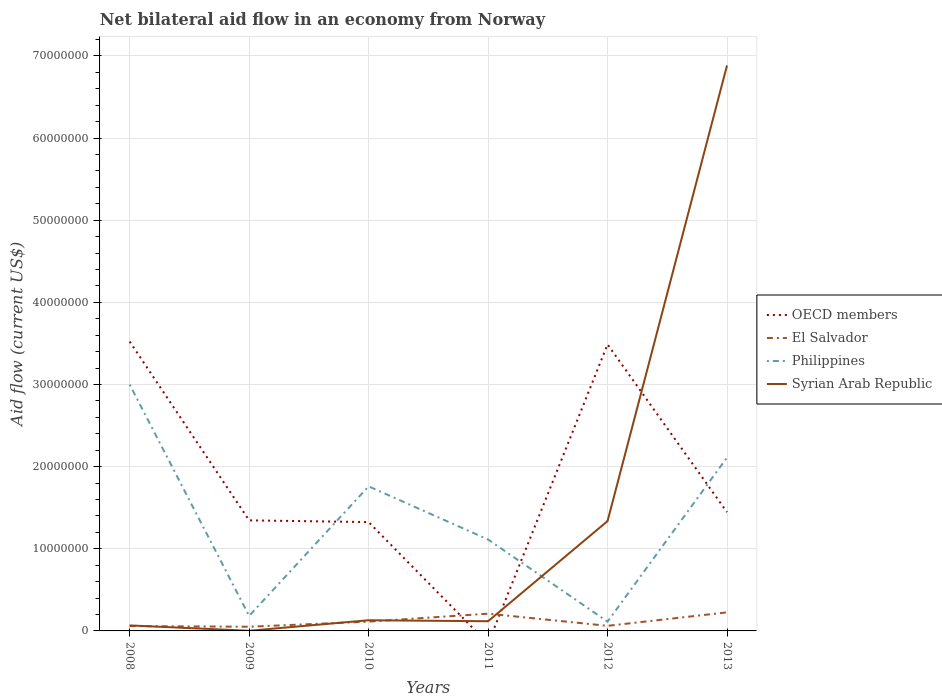Does the line corresponding to El Salvador intersect with the line corresponding to OECD members?
Make the answer very short. Yes. Is the number of lines equal to the number of legend labels?
Ensure brevity in your answer.  No. Across all years, what is the maximum net bilateral aid flow in El Salvador?
Provide a succinct answer. 5.10e+05. What is the total net bilateral aid flow in El Salvador in the graph?
Make the answer very short. 8.00e+04. What is the difference between the highest and the second highest net bilateral aid flow in Philippines?
Provide a short and direct response. 2.89e+07. Are the values on the major ticks of Y-axis written in scientific E-notation?
Ensure brevity in your answer.  No. Does the graph contain grids?
Your answer should be compact. Yes. Where does the legend appear in the graph?
Keep it short and to the point. Center right. How many legend labels are there?
Offer a terse response. 4. What is the title of the graph?
Provide a succinct answer. Net bilateral aid flow in an economy from Norway. Does "Faeroe Islands" appear as one of the legend labels in the graph?
Make the answer very short. No. What is the Aid flow (current US$) in OECD members in 2008?
Offer a terse response. 3.52e+07. What is the Aid flow (current US$) of El Salvador in 2008?
Provide a short and direct response. 5.90e+05. What is the Aid flow (current US$) in Philippines in 2008?
Offer a terse response. 3.00e+07. What is the Aid flow (current US$) in Syrian Arab Republic in 2008?
Give a very brief answer. 6.70e+05. What is the Aid flow (current US$) of OECD members in 2009?
Keep it short and to the point. 1.35e+07. What is the Aid flow (current US$) in El Salvador in 2009?
Give a very brief answer. 5.10e+05. What is the Aid flow (current US$) of Philippines in 2009?
Offer a terse response. 1.83e+06. What is the Aid flow (current US$) of Syrian Arab Republic in 2009?
Give a very brief answer. 2.00e+04. What is the Aid flow (current US$) in OECD members in 2010?
Provide a succinct answer. 1.32e+07. What is the Aid flow (current US$) of El Salvador in 2010?
Your response must be concise. 1.13e+06. What is the Aid flow (current US$) of Philippines in 2010?
Make the answer very short. 1.76e+07. What is the Aid flow (current US$) of Syrian Arab Republic in 2010?
Your answer should be compact. 1.30e+06. What is the Aid flow (current US$) of El Salvador in 2011?
Provide a succinct answer. 2.10e+06. What is the Aid flow (current US$) of Philippines in 2011?
Make the answer very short. 1.11e+07. What is the Aid flow (current US$) in Syrian Arab Republic in 2011?
Make the answer very short. 1.18e+06. What is the Aid flow (current US$) in OECD members in 2012?
Your answer should be compact. 3.49e+07. What is the Aid flow (current US$) of El Salvador in 2012?
Keep it short and to the point. 6.20e+05. What is the Aid flow (current US$) in Philippines in 2012?
Keep it short and to the point. 1.13e+06. What is the Aid flow (current US$) of Syrian Arab Republic in 2012?
Give a very brief answer. 1.34e+07. What is the Aid flow (current US$) in OECD members in 2013?
Give a very brief answer. 1.45e+07. What is the Aid flow (current US$) of El Salvador in 2013?
Ensure brevity in your answer.  2.26e+06. What is the Aid flow (current US$) in Philippines in 2013?
Keep it short and to the point. 2.11e+07. What is the Aid flow (current US$) of Syrian Arab Republic in 2013?
Give a very brief answer. 6.88e+07. Across all years, what is the maximum Aid flow (current US$) in OECD members?
Your answer should be compact. 3.52e+07. Across all years, what is the maximum Aid flow (current US$) of El Salvador?
Provide a succinct answer. 2.26e+06. Across all years, what is the maximum Aid flow (current US$) in Philippines?
Your response must be concise. 3.00e+07. Across all years, what is the maximum Aid flow (current US$) in Syrian Arab Republic?
Make the answer very short. 6.88e+07. Across all years, what is the minimum Aid flow (current US$) in OECD members?
Make the answer very short. 0. Across all years, what is the minimum Aid flow (current US$) in El Salvador?
Ensure brevity in your answer.  5.10e+05. Across all years, what is the minimum Aid flow (current US$) in Philippines?
Give a very brief answer. 1.13e+06. What is the total Aid flow (current US$) of OECD members in the graph?
Keep it short and to the point. 1.11e+08. What is the total Aid flow (current US$) of El Salvador in the graph?
Provide a short and direct response. 7.21e+06. What is the total Aid flow (current US$) of Philippines in the graph?
Your answer should be very brief. 8.28e+07. What is the total Aid flow (current US$) in Syrian Arab Republic in the graph?
Your response must be concise. 8.54e+07. What is the difference between the Aid flow (current US$) in OECD members in 2008 and that in 2009?
Make the answer very short. 2.18e+07. What is the difference between the Aid flow (current US$) in El Salvador in 2008 and that in 2009?
Your answer should be very brief. 8.00e+04. What is the difference between the Aid flow (current US$) in Philippines in 2008 and that in 2009?
Ensure brevity in your answer.  2.82e+07. What is the difference between the Aid flow (current US$) in Syrian Arab Republic in 2008 and that in 2009?
Offer a terse response. 6.50e+05. What is the difference between the Aid flow (current US$) of OECD members in 2008 and that in 2010?
Give a very brief answer. 2.20e+07. What is the difference between the Aid flow (current US$) of El Salvador in 2008 and that in 2010?
Your answer should be compact. -5.40e+05. What is the difference between the Aid flow (current US$) in Philippines in 2008 and that in 2010?
Your answer should be very brief. 1.24e+07. What is the difference between the Aid flow (current US$) in Syrian Arab Republic in 2008 and that in 2010?
Keep it short and to the point. -6.30e+05. What is the difference between the Aid flow (current US$) of El Salvador in 2008 and that in 2011?
Your answer should be very brief. -1.51e+06. What is the difference between the Aid flow (current US$) in Philippines in 2008 and that in 2011?
Offer a very short reply. 1.89e+07. What is the difference between the Aid flow (current US$) of Syrian Arab Republic in 2008 and that in 2011?
Make the answer very short. -5.10e+05. What is the difference between the Aid flow (current US$) of El Salvador in 2008 and that in 2012?
Make the answer very short. -3.00e+04. What is the difference between the Aid flow (current US$) in Philippines in 2008 and that in 2012?
Make the answer very short. 2.89e+07. What is the difference between the Aid flow (current US$) in Syrian Arab Republic in 2008 and that in 2012?
Make the answer very short. -1.27e+07. What is the difference between the Aid flow (current US$) in OECD members in 2008 and that in 2013?
Keep it short and to the point. 2.08e+07. What is the difference between the Aid flow (current US$) of El Salvador in 2008 and that in 2013?
Offer a terse response. -1.67e+06. What is the difference between the Aid flow (current US$) of Philippines in 2008 and that in 2013?
Make the answer very short. 8.88e+06. What is the difference between the Aid flow (current US$) of Syrian Arab Republic in 2008 and that in 2013?
Make the answer very short. -6.82e+07. What is the difference between the Aid flow (current US$) in El Salvador in 2009 and that in 2010?
Keep it short and to the point. -6.20e+05. What is the difference between the Aid flow (current US$) of Philippines in 2009 and that in 2010?
Your response must be concise. -1.58e+07. What is the difference between the Aid flow (current US$) of Syrian Arab Republic in 2009 and that in 2010?
Offer a terse response. -1.28e+06. What is the difference between the Aid flow (current US$) in El Salvador in 2009 and that in 2011?
Provide a short and direct response. -1.59e+06. What is the difference between the Aid flow (current US$) of Philippines in 2009 and that in 2011?
Give a very brief answer. -9.30e+06. What is the difference between the Aid flow (current US$) in Syrian Arab Republic in 2009 and that in 2011?
Offer a very short reply. -1.16e+06. What is the difference between the Aid flow (current US$) in OECD members in 2009 and that in 2012?
Provide a succinct answer. -2.14e+07. What is the difference between the Aid flow (current US$) of El Salvador in 2009 and that in 2012?
Your answer should be compact. -1.10e+05. What is the difference between the Aid flow (current US$) of Philippines in 2009 and that in 2012?
Offer a terse response. 7.00e+05. What is the difference between the Aid flow (current US$) of Syrian Arab Republic in 2009 and that in 2012?
Your response must be concise. -1.34e+07. What is the difference between the Aid flow (current US$) of OECD members in 2009 and that in 2013?
Give a very brief answer. -1.00e+06. What is the difference between the Aid flow (current US$) in El Salvador in 2009 and that in 2013?
Your response must be concise. -1.75e+06. What is the difference between the Aid flow (current US$) of Philippines in 2009 and that in 2013?
Your answer should be very brief. -1.93e+07. What is the difference between the Aid flow (current US$) in Syrian Arab Republic in 2009 and that in 2013?
Keep it short and to the point. -6.88e+07. What is the difference between the Aid flow (current US$) of El Salvador in 2010 and that in 2011?
Provide a succinct answer. -9.70e+05. What is the difference between the Aid flow (current US$) in Philippines in 2010 and that in 2011?
Your response must be concise. 6.47e+06. What is the difference between the Aid flow (current US$) in OECD members in 2010 and that in 2012?
Your response must be concise. -2.16e+07. What is the difference between the Aid flow (current US$) in El Salvador in 2010 and that in 2012?
Your response must be concise. 5.10e+05. What is the difference between the Aid flow (current US$) in Philippines in 2010 and that in 2012?
Keep it short and to the point. 1.65e+07. What is the difference between the Aid flow (current US$) of Syrian Arab Republic in 2010 and that in 2012?
Your answer should be compact. -1.21e+07. What is the difference between the Aid flow (current US$) of OECD members in 2010 and that in 2013?
Your answer should be very brief. -1.21e+06. What is the difference between the Aid flow (current US$) in El Salvador in 2010 and that in 2013?
Offer a very short reply. -1.13e+06. What is the difference between the Aid flow (current US$) of Philippines in 2010 and that in 2013?
Provide a succinct answer. -3.51e+06. What is the difference between the Aid flow (current US$) of Syrian Arab Republic in 2010 and that in 2013?
Your answer should be very brief. -6.75e+07. What is the difference between the Aid flow (current US$) in El Salvador in 2011 and that in 2012?
Your response must be concise. 1.48e+06. What is the difference between the Aid flow (current US$) in Syrian Arab Republic in 2011 and that in 2012?
Your response must be concise. -1.22e+07. What is the difference between the Aid flow (current US$) in Philippines in 2011 and that in 2013?
Offer a very short reply. -9.98e+06. What is the difference between the Aid flow (current US$) in Syrian Arab Republic in 2011 and that in 2013?
Give a very brief answer. -6.77e+07. What is the difference between the Aid flow (current US$) of OECD members in 2012 and that in 2013?
Offer a terse response. 2.04e+07. What is the difference between the Aid flow (current US$) in El Salvador in 2012 and that in 2013?
Offer a very short reply. -1.64e+06. What is the difference between the Aid flow (current US$) of Philippines in 2012 and that in 2013?
Your answer should be very brief. -2.00e+07. What is the difference between the Aid flow (current US$) of Syrian Arab Republic in 2012 and that in 2013?
Provide a succinct answer. -5.55e+07. What is the difference between the Aid flow (current US$) of OECD members in 2008 and the Aid flow (current US$) of El Salvador in 2009?
Your answer should be compact. 3.47e+07. What is the difference between the Aid flow (current US$) of OECD members in 2008 and the Aid flow (current US$) of Philippines in 2009?
Keep it short and to the point. 3.34e+07. What is the difference between the Aid flow (current US$) of OECD members in 2008 and the Aid flow (current US$) of Syrian Arab Republic in 2009?
Offer a terse response. 3.52e+07. What is the difference between the Aid flow (current US$) of El Salvador in 2008 and the Aid flow (current US$) of Philippines in 2009?
Keep it short and to the point. -1.24e+06. What is the difference between the Aid flow (current US$) in El Salvador in 2008 and the Aid flow (current US$) in Syrian Arab Republic in 2009?
Your answer should be very brief. 5.70e+05. What is the difference between the Aid flow (current US$) of Philippines in 2008 and the Aid flow (current US$) of Syrian Arab Republic in 2009?
Your response must be concise. 3.00e+07. What is the difference between the Aid flow (current US$) in OECD members in 2008 and the Aid flow (current US$) in El Salvador in 2010?
Ensure brevity in your answer.  3.41e+07. What is the difference between the Aid flow (current US$) in OECD members in 2008 and the Aid flow (current US$) in Philippines in 2010?
Offer a terse response. 1.76e+07. What is the difference between the Aid flow (current US$) in OECD members in 2008 and the Aid flow (current US$) in Syrian Arab Republic in 2010?
Provide a short and direct response. 3.39e+07. What is the difference between the Aid flow (current US$) in El Salvador in 2008 and the Aid flow (current US$) in Philippines in 2010?
Make the answer very short. -1.70e+07. What is the difference between the Aid flow (current US$) in El Salvador in 2008 and the Aid flow (current US$) in Syrian Arab Republic in 2010?
Keep it short and to the point. -7.10e+05. What is the difference between the Aid flow (current US$) in Philippines in 2008 and the Aid flow (current US$) in Syrian Arab Republic in 2010?
Your response must be concise. 2.87e+07. What is the difference between the Aid flow (current US$) in OECD members in 2008 and the Aid flow (current US$) in El Salvador in 2011?
Keep it short and to the point. 3.31e+07. What is the difference between the Aid flow (current US$) of OECD members in 2008 and the Aid flow (current US$) of Philippines in 2011?
Provide a short and direct response. 2.41e+07. What is the difference between the Aid flow (current US$) of OECD members in 2008 and the Aid flow (current US$) of Syrian Arab Republic in 2011?
Give a very brief answer. 3.40e+07. What is the difference between the Aid flow (current US$) of El Salvador in 2008 and the Aid flow (current US$) of Philippines in 2011?
Provide a short and direct response. -1.05e+07. What is the difference between the Aid flow (current US$) of El Salvador in 2008 and the Aid flow (current US$) of Syrian Arab Republic in 2011?
Ensure brevity in your answer.  -5.90e+05. What is the difference between the Aid flow (current US$) of Philippines in 2008 and the Aid flow (current US$) of Syrian Arab Republic in 2011?
Make the answer very short. 2.88e+07. What is the difference between the Aid flow (current US$) in OECD members in 2008 and the Aid flow (current US$) in El Salvador in 2012?
Give a very brief answer. 3.46e+07. What is the difference between the Aid flow (current US$) of OECD members in 2008 and the Aid flow (current US$) of Philippines in 2012?
Offer a terse response. 3.41e+07. What is the difference between the Aid flow (current US$) in OECD members in 2008 and the Aid flow (current US$) in Syrian Arab Republic in 2012?
Your answer should be very brief. 2.19e+07. What is the difference between the Aid flow (current US$) in El Salvador in 2008 and the Aid flow (current US$) in Philippines in 2012?
Your answer should be very brief. -5.40e+05. What is the difference between the Aid flow (current US$) of El Salvador in 2008 and the Aid flow (current US$) of Syrian Arab Republic in 2012?
Your response must be concise. -1.28e+07. What is the difference between the Aid flow (current US$) in Philippines in 2008 and the Aid flow (current US$) in Syrian Arab Republic in 2012?
Offer a very short reply. 1.66e+07. What is the difference between the Aid flow (current US$) in OECD members in 2008 and the Aid flow (current US$) in El Salvador in 2013?
Your answer should be very brief. 3.30e+07. What is the difference between the Aid flow (current US$) of OECD members in 2008 and the Aid flow (current US$) of Philippines in 2013?
Offer a very short reply. 1.41e+07. What is the difference between the Aid flow (current US$) in OECD members in 2008 and the Aid flow (current US$) in Syrian Arab Republic in 2013?
Your answer should be compact. -3.36e+07. What is the difference between the Aid flow (current US$) in El Salvador in 2008 and the Aid flow (current US$) in Philippines in 2013?
Offer a terse response. -2.05e+07. What is the difference between the Aid flow (current US$) of El Salvador in 2008 and the Aid flow (current US$) of Syrian Arab Republic in 2013?
Your answer should be very brief. -6.82e+07. What is the difference between the Aid flow (current US$) of Philippines in 2008 and the Aid flow (current US$) of Syrian Arab Republic in 2013?
Give a very brief answer. -3.88e+07. What is the difference between the Aid flow (current US$) of OECD members in 2009 and the Aid flow (current US$) of El Salvador in 2010?
Give a very brief answer. 1.23e+07. What is the difference between the Aid flow (current US$) in OECD members in 2009 and the Aid flow (current US$) in Philippines in 2010?
Keep it short and to the point. -4.14e+06. What is the difference between the Aid flow (current US$) of OECD members in 2009 and the Aid flow (current US$) of Syrian Arab Republic in 2010?
Provide a short and direct response. 1.22e+07. What is the difference between the Aid flow (current US$) in El Salvador in 2009 and the Aid flow (current US$) in Philippines in 2010?
Offer a very short reply. -1.71e+07. What is the difference between the Aid flow (current US$) in El Salvador in 2009 and the Aid flow (current US$) in Syrian Arab Republic in 2010?
Your response must be concise. -7.90e+05. What is the difference between the Aid flow (current US$) in Philippines in 2009 and the Aid flow (current US$) in Syrian Arab Republic in 2010?
Your answer should be very brief. 5.30e+05. What is the difference between the Aid flow (current US$) of OECD members in 2009 and the Aid flow (current US$) of El Salvador in 2011?
Your answer should be compact. 1.14e+07. What is the difference between the Aid flow (current US$) in OECD members in 2009 and the Aid flow (current US$) in Philippines in 2011?
Offer a terse response. 2.33e+06. What is the difference between the Aid flow (current US$) of OECD members in 2009 and the Aid flow (current US$) of Syrian Arab Republic in 2011?
Your response must be concise. 1.23e+07. What is the difference between the Aid flow (current US$) in El Salvador in 2009 and the Aid flow (current US$) in Philippines in 2011?
Make the answer very short. -1.06e+07. What is the difference between the Aid flow (current US$) in El Salvador in 2009 and the Aid flow (current US$) in Syrian Arab Republic in 2011?
Keep it short and to the point. -6.70e+05. What is the difference between the Aid flow (current US$) of Philippines in 2009 and the Aid flow (current US$) of Syrian Arab Republic in 2011?
Your answer should be very brief. 6.50e+05. What is the difference between the Aid flow (current US$) of OECD members in 2009 and the Aid flow (current US$) of El Salvador in 2012?
Your answer should be compact. 1.28e+07. What is the difference between the Aid flow (current US$) in OECD members in 2009 and the Aid flow (current US$) in Philippines in 2012?
Give a very brief answer. 1.23e+07. What is the difference between the Aid flow (current US$) of El Salvador in 2009 and the Aid flow (current US$) of Philippines in 2012?
Ensure brevity in your answer.  -6.20e+05. What is the difference between the Aid flow (current US$) in El Salvador in 2009 and the Aid flow (current US$) in Syrian Arab Republic in 2012?
Give a very brief answer. -1.29e+07. What is the difference between the Aid flow (current US$) of Philippines in 2009 and the Aid flow (current US$) of Syrian Arab Republic in 2012?
Your answer should be compact. -1.15e+07. What is the difference between the Aid flow (current US$) of OECD members in 2009 and the Aid flow (current US$) of El Salvador in 2013?
Your answer should be compact. 1.12e+07. What is the difference between the Aid flow (current US$) of OECD members in 2009 and the Aid flow (current US$) of Philippines in 2013?
Give a very brief answer. -7.65e+06. What is the difference between the Aid flow (current US$) of OECD members in 2009 and the Aid flow (current US$) of Syrian Arab Republic in 2013?
Provide a short and direct response. -5.54e+07. What is the difference between the Aid flow (current US$) in El Salvador in 2009 and the Aid flow (current US$) in Philippines in 2013?
Provide a succinct answer. -2.06e+07. What is the difference between the Aid flow (current US$) of El Salvador in 2009 and the Aid flow (current US$) of Syrian Arab Republic in 2013?
Give a very brief answer. -6.83e+07. What is the difference between the Aid flow (current US$) in Philippines in 2009 and the Aid flow (current US$) in Syrian Arab Republic in 2013?
Keep it short and to the point. -6.70e+07. What is the difference between the Aid flow (current US$) of OECD members in 2010 and the Aid flow (current US$) of El Salvador in 2011?
Keep it short and to the point. 1.12e+07. What is the difference between the Aid flow (current US$) of OECD members in 2010 and the Aid flow (current US$) of Philippines in 2011?
Make the answer very short. 2.12e+06. What is the difference between the Aid flow (current US$) of OECD members in 2010 and the Aid flow (current US$) of Syrian Arab Republic in 2011?
Your answer should be very brief. 1.21e+07. What is the difference between the Aid flow (current US$) of El Salvador in 2010 and the Aid flow (current US$) of Philippines in 2011?
Keep it short and to the point. -1.00e+07. What is the difference between the Aid flow (current US$) of Philippines in 2010 and the Aid flow (current US$) of Syrian Arab Republic in 2011?
Keep it short and to the point. 1.64e+07. What is the difference between the Aid flow (current US$) in OECD members in 2010 and the Aid flow (current US$) in El Salvador in 2012?
Keep it short and to the point. 1.26e+07. What is the difference between the Aid flow (current US$) in OECD members in 2010 and the Aid flow (current US$) in Philippines in 2012?
Provide a short and direct response. 1.21e+07. What is the difference between the Aid flow (current US$) in OECD members in 2010 and the Aid flow (current US$) in Syrian Arab Republic in 2012?
Provide a short and direct response. -1.20e+05. What is the difference between the Aid flow (current US$) in El Salvador in 2010 and the Aid flow (current US$) in Syrian Arab Republic in 2012?
Your answer should be compact. -1.22e+07. What is the difference between the Aid flow (current US$) of Philippines in 2010 and the Aid flow (current US$) of Syrian Arab Republic in 2012?
Your response must be concise. 4.23e+06. What is the difference between the Aid flow (current US$) of OECD members in 2010 and the Aid flow (current US$) of El Salvador in 2013?
Make the answer very short. 1.10e+07. What is the difference between the Aid flow (current US$) of OECD members in 2010 and the Aid flow (current US$) of Philippines in 2013?
Provide a short and direct response. -7.86e+06. What is the difference between the Aid flow (current US$) in OECD members in 2010 and the Aid flow (current US$) in Syrian Arab Republic in 2013?
Keep it short and to the point. -5.56e+07. What is the difference between the Aid flow (current US$) of El Salvador in 2010 and the Aid flow (current US$) of Philippines in 2013?
Ensure brevity in your answer.  -2.00e+07. What is the difference between the Aid flow (current US$) of El Salvador in 2010 and the Aid flow (current US$) of Syrian Arab Republic in 2013?
Make the answer very short. -6.77e+07. What is the difference between the Aid flow (current US$) in Philippines in 2010 and the Aid flow (current US$) in Syrian Arab Republic in 2013?
Ensure brevity in your answer.  -5.12e+07. What is the difference between the Aid flow (current US$) of El Salvador in 2011 and the Aid flow (current US$) of Philippines in 2012?
Offer a very short reply. 9.70e+05. What is the difference between the Aid flow (current US$) of El Salvador in 2011 and the Aid flow (current US$) of Syrian Arab Republic in 2012?
Provide a succinct answer. -1.13e+07. What is the difference between the Aid flow (current US$) of Philippines in 2011 and the Aid flow (current US$) of Syrian Arab Republic in 2012?
Give a very brief answer. -2.24e+06. What is the difference between the Aid flow (current US$) in El Salvador in 2011 and the Aid flow (current US$) in Philippines in 2013?
Your answer should be very brief. -1.90e+07. What is the difference between the Aid flow (current US$) of El Salvador in 2011 and the Aid flow (current US$) of Syrian Arab Republic in 2013?
Provide a short and direct response. -6.67e+07. What is the difference between the Aid flow (current US$) of Philippines in 2011 and the Aid flow (current US$) of Syrian Arab Republic in 2013?
Your answer should be compact. -5.77e+07. What is the difference between the Aid flow (current US$) of OECD members in 2012 and the Aid flow (current US$) of El Salvador in 2013?
Your answer should be very brief. 3.26e+07. What is the difference between the Aid flow (current US$) of OECD members in 2012 and the Aid flow (current US$) of Philippines in 2013?
Your answer should be very brief. 1.38e+07. What is the difference between the Aid flow (current US$) of OECD members in 2012 and the Aid flow (current US$) of Syrian Arab Republic in 2013?
Make the answer very short. -3.40e+07. What is the difference between the Aid flow (current US$) in El Salvador in 2012 and the Aid flow (current US$) in Philippines in 2013?
Provide a succinct answer. -2.05e+07. What is the difference between the Aid flow (current US$) in El Salvador in 2012 and the Aid flow (current US$) in Syrian Arab Republic in 2013?
Give a very brief answer. -6.82e+07. What is the difference between the Aid flow (current US$) in Philippines in 2012 and the Aid flow (current US$) in Syrian Arab Republic in 2013?
Make the answer very short. -6.77e+07. What is the average Aid flow (current US$) of OECD members per year?
Your response must be concise. 1.85e+07. What is the average Aid flow (current US$) of El Salvador per year?
Keep it short and to the point. 1.20e+06. What is the average Aid flow (current US$) of Philippines per year?
Provide a succinct answer. 1.38e+07. What is the average Aid flow (current US$) in Syrian Arab Republic per year?
Make the answer very short. 1.42e+07. In the year 2008, what is the difference between the Aid flow (current US$) in OECD members and Aid flow (current US$) in El Salvador?
Your answer should be very brief. 3.46e+07. In the year 2008, what is the difference between the Aid flow (current US$) of OECD members and Aid flow (current US$) of Philippines?
Your response must be concise. 5.24e+06. In the year 2008, what is the difference between the Aid flow (current US$) of OECD members and Aid flow (current US$) of Syrian Arab Republic?
Provide a succinct answer. 3.46e+07. In the year 2008, what is the difference between the Aid flow (current US$) in El Salvador and Aid flow (current US$) in Philippines?
Ensure brevity in your answer.  -2.94e+07. In the year 2008, what is the difference between the Aid flow (current US$) of Philippines and Aid flow (current US$) of Syrian Arab Republic?
Provide a succinct answer. 2.93e+07. In the year 2009, what is the difference between the Aid flow (current US$) of OECD members and Aid flow (current US$) of El Salvador?
Your answer should be compact. 1.30e+07. In the year 2009, what is the difference between the Aid flow (current US$) in OECD members and Aid flow (current US$) in Philippines?
Offer a terse response. 1.16e+07. In the year 2009, what is the difference between the Aid flow (current US$) in OECD members and Aid flow (current US$) in Syrian Arab Republic?
Offer a terse response. 1.34e+07. In the year 2009, what is the difference between the Aid flow (current US$) in El Salvador and Aid flow (current US$) in Philippines?
Your answer should be very brief. -1.32e+06. In the year 2009, what is the difference between the Aid flow (current US$) of Philippines and Aid flow (current US$) of Syrian Arab Republic?
Provide a succinct answer. 1.81e+06. In the year 2010, what is the difference between the Aid flow (current US$) in OECD members and Aid flow (current US$) in El Salvador?
Your response must be concise. 1.21e+07. In the year 2010, what is the difference between the Aid flow (current US$) of OECD members and Aid flow (current US$) of Philippines?
Give a very brief answer. -4.35e+06. In the year 2010, what is the difference between the Aid flow (current US$) of OECD members and Aid flow (current US$) of Syrian Arab Republic?
Your answer should be compact. 1.20e+07. In the year 2010, what is the difference between the Aid flow (current US$) of El Salvador and Aid flow (current US$) of Philippines?
Offer a terse response. -1.65e+07. In the year 2010, what is the difference between the Aid flow (current US$) in Philippines and Aid flow (current US$) in Syrian Arab Republic?
Your answer should be compact. 1.63e+07. In the year 2011, what is the difference between the Aid flow (current US$) of El Salvador and Aid flow (current US$) of Philippines?
Give a very brief answer. -9.03e+06. In the year 2011, what is the difference between the Aid flow (current US$) of El Salvador and Aid flow (current US$) of Syrian Arab Republic?
Make the answer very short. 9.20e+05. In the year 2011, what is the difference between the Aid flow (current US$) of Philippines and Aid flow (current US$) of Syrian Arab Republic?
Keep it short and to the point. 9.95e+06. In the year 2012, what is the difference between the Aid flow (current US$) in OECD members and Aid flow (current US$) in El Salvador?
Offer a very short reply. 3.43e+07. In the year 2012, what is the difference between the Aid flow (current US$) in OECD members and Aid flow (current US$) in Philippines?
Keep it short and to the point. 3.38e+07. In the year 2012, what is the difference between the Aid flow (current US$) in OECD members and Aid flow (current US$) in Syrian Arab Republic?
Your answer should be compact. 2.15e+07. In the year 2012, what is the difference between the Aid flow (current US$) of El Salvador and Aid flow (current US$) of Philippines?
Your answer should be compact. -5.10e+05. In the year 2012, what is the difference between the Aid flow (current US$) in El Salvador and Aid flow (current US$) in Syrian Arab Republic?
Keep it short and to the point. -1.28e+07. In the year 2012, what is the difference between the Aid flow (current US$) in Philippines and Aid flow (current US$) in Syrian Arab Republic?
Your answer should be compact. -1.22e+07. In the year 2013, what is the difference between the Aid flow (current US$) of OECD members and Aid flow (current US$) of El Salvador?
Ensure brevity in your answer.  1.22e+07. In the year 2013, what is the difference between the Aid flow (current US$) of OECD members and Aid flow (current US$) of Philippines?
Provide a succinct answer. -6.65e+06. In the year 2013, what is the difference between the Aid flow (current US$) in OECD members and Aid flow (current US$) in Syrian Arab Republic?
Make the answer very short. -5.44e+07. In the year 2013, what is the difference between the Aid flow (current US$) of El Salvador and Aid flow (current US$) of Philippines?
Make the answer very short. -1.88e+07. In the year 2013, what is the difference between the Aid flow (current US$) of El Salvador and Aid flow (current US$) of Syrian Arab Republic?
Keep it short and to the point. -6.66e+07. In the year 2013, what is the difference between the Aid flow (current US$) of Philippines and Aid flow (current US$) of Syrian Arab Republic?
Offer a terse response. -4.77e+07. What is the ratio of the Aid flow (current US$) in OECD members in 2008 to that in 2009?
Provide a short and direct response. 2.62. What is the ratio of the Aid flow (current US$) in El Salvador in 2008 to that in 2009?
Make the answer very short. 1.16. What is the ratio of the Aid flow (current US$) of Philippines in 2008 to that in 2009?
Make the answer very short. 16.39. What is the ratio of the Aid flow (current US$) in Syrian Arab Republic in 2008 to that in 2009?
Give a very brief answer. 33.5. What is the ratio of the Aid flow (current US$) of OECD members in 2008 to that in 2010?
Ensure brevity in your answer.  2.66. What is the ratio of the Aid flow (current US$) of El Salvador in 2008 to that in 2010?
Make the answer very short. 0.52. What is the ratio of the Aid flow (current US$) in Philippines in 2008 to that in 2010?
Offer a terse response. 1.7. What is the ratio of the Aid flow (current US$) of Syrian Arab Republic in 2008 to that in 2010?
Keep it short and to the point. 0.52. What is the ratio of the Aid flow (current US$) of El Salvador in 2008 to that in 2011?
Provide a succinct answer. 0.28. What is the ratio of the Aid flow (current US$) in Philippines in 2008 to that in 2011?
Your answer should be very brief. 2.69. What is the ratio of the Aid flow (current US$) in Syrian Arab Republic in 2008 to that in 2011?
Provide a short and direct response. 0.57. What is the ratio of the Aid flow (current US$) of El Salvador in 2008 to that in 2012?
Your answer should be compact. 0.95. What is the ratio of the Aid flow (current US$) of Philippines in 2008 to that in 2012?
Give a very brief answer. 26.54. What is the ratio of the Aid flow (current US$) in Syrian Arab Republic in 2008 to that in 2012?
Provide a short and direct response. 0.05. What is the ratio of the Aid flow (current US$) in OECD members in 2008 to that in 2013?
Make the answer very short. 2.44. What is the ratio of the Aid flow (current US$) in El Salvador in 2008 to that in 2013?
Your response must be concise. 0.26. What is the ratio of the Aid flow (current US$) of Philippines in 2008 to that in 2013?
Offer a very short reply. 1.42. What is the ratio of the Aid flow (current US$) in Syrian Arab Republic in 2008 to that in 2013?
Provide a succinct answer. 0.01. What is the ratio of the Aid flow (current US$) in OECD members in 2009 to that in 2010?
Your answer should be very brief. 1.02. What is the ratio of the Aid flow (current US$) in El Salvador in 2009 to that in 2010?
Offer a very short reply. 0.45. What is the ratio of the Aid flow (current US$) of Philippines in 2009 to that in 2010?
Offer a terse response. 0.1. What is the ratio of the Aid flow (current US$) of Syrian Arab Republic in 2009 to that in 2010?
Your response must be concise. 0.02. What is the ratio of the Aid flow (current US$) in El Salvador in 2009 to that in 2011?
Keep it short and to the point. 0.24. What is the ratio of the Aid flow (current US$) of Philippines in 2009 to that in 2011?
Give a very brief answer. 0.16. What is the ratio of the Aid flow (current US$) of Syrian Arab Republic in 2009 to that in 2011?
Keep it short and to the point. 0.02. What is the ratio of the Aid flow (current US$) in OECD members in 2009 to that in 2012?
Your response must be concise. 0.39. What is the ratio of the Aid flow (current US$) in El Salvador in 2009 to that in 2012?
Make the answer very short. 0.82. What is the ratio of the Aid flow (current US$) in Philippines in 2009 to that in 2012?
Give a very brief answer. 1.62. What is the ratio of the Aid flow (current US$) in Syrian Arab Republic in 2009 to that in 2012?
Give a very brief answer. 0. What is the ratio of the Aid flow (current US$) in OECD members in 2009 to that in 2013?
Keep it short and to the point. 0.93. What is the ratio of the Aid flow (current US$) of El Salvador in 2009 to that in 2013?
Ensure brevity in your answer.  0.23. What is the ratio of the Aid flow (current US$) of Philippines in 2009 to that in 2013?
Provide a short and direct response. 0.09. What is the ratio of the Aid flow (current US$) of Syrian Arab Republic in 2009 to that in 2013?
Offer a very short reply. 0. What is the ratio of the Aid flow (current US$) in El Salvador in 2010 to that in 2011?
Provide a succinct answer. 0.54. What is the ratio of the Aid flow (current US$) in Philippines in 2010 to that in 2011?
Offer a very short reply. 1.58. What is the ratio of the Aid flow (current US$) in Syrian Arab Republic in 2010 to that in 2011?
Ensure brevity in your answer.  1.1. What is the ratio of the Aid flow (current US$) in OECD members in 2010 to that in 2012?
Your response must be concise. 0.38. What is the ratio of the Aid flow (current US$) of El Salvador in 2010 to that in 2012?
Offer a terse response. 1.82. What is the ratio of the Aid flow (current US$) of Philippines in 2010 to that in 2012?
Make the answer very short. 15.58. What is the ratio of the Aid flow (current US$) of Syrian Arab Republic in 2010 to that in 2012?
Provide a succinct answer. 0.1. What is the ratio of the Aid flow (current US$) in OECD members in 2010 to that in 2013?
Give a very brief answer. 0.92. What is the ratio of the Aid flow (current US$) of Philippines in 2010 to that in 2013?
Offer a terse response. 0.83. What is the ratio of the Aid flow (current US$) of Syrian Arab Republic in 2010 to that in 2013?
Provide a short and direct response. 0.02. What is the ratio of the Aid flow (current US$) of El Salvador in 2011 to that in 2012?
Offer a terse response. 3.39. What is the ratio of the Aid flow (current US$) in Philippines in 2011 to that in 2012?
Keep it short and to the point. 9.85. What is the ratio of the Aid flow (current US$) of Syrian Arab Republic in 2011 to that in 2012?
Ensure brevity in your answer.  0.09. What is the ratio of the Aid flow (current US$) of El Salvador in 2011 to that in 2013?
Provide a short and direct response. 0.93. What is the ratio of the Aid flow (current US$) in Philippines in 2011 to that in 2013?
Provide a short and direct response. 0.53. What is the ratio of the Aid flow (current US$) of Syrian Arab Republic in 2011 to that in 2013?
Offer a very short reply. 0.02. What is the ratio of the Aid flow (current US$) of OECD members in 2012 to that in 2013?
Provide a succinct answer. 2.41. What is the ratio of the Aid flow (current US$) in El Salvador in 2012 to that in 2013?
Ensure brevity in your answer.  0.27. What is the ratio of the Aid flow (current US$) of Philippines in 2012 to that in 2013?
Give a very brief answer. 0.05. What is the ratio of the Aid flow (current US$) of Syrian Arab Republic in 2012 to that in 2013?
Give a very brief answer. 0.19. What is the difference between the highest and the second highest Aid flow (current US$) in El Salvador?
Offer a terse response. 1.60e+05. What is the difference between the highest and the second highest Aid flow (current US$) in Philippines?
Ensure brevity in your answer.  8.88e+06. What is the difference between the highest and the second highest Aid flow (current US$) in Syrian Arab Republic?
Provide a succinct answer. 5.55e+07. What is the difference between the highest and the lowest Aid flow (current US$) in OECD members?
Provide a short and direct response. 3.52e+07. What is the difference between the highest and the lowest Aid flow (current US$) in El Salvador?
Make the answer very short. 1.75e+06. What is the difference between the highest and the lowest Aid flow (current US$) of Philippines?
Your response must be concise. 2.89e+07. What is the difference between the highest and the lowest Aid flow (current US$) in Syrian Arab Republic?
Give a very brief answer. 6.88e+07. 